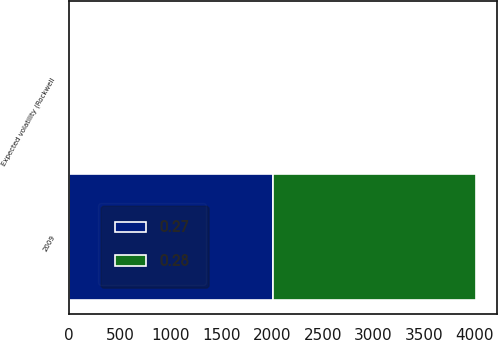Convert chart to OTSL. <chart><loc_0><loc_0><loc_500><loc_500><stacked_bar_chart><ecel><fcel>2009<fcel>Expected volatility (Rockwell<nl><fcel>0.27<fcel>2008<fcel>0.27<nl><fcel>0.28<fcel>2007<fcel>0.28<nl></chart> 